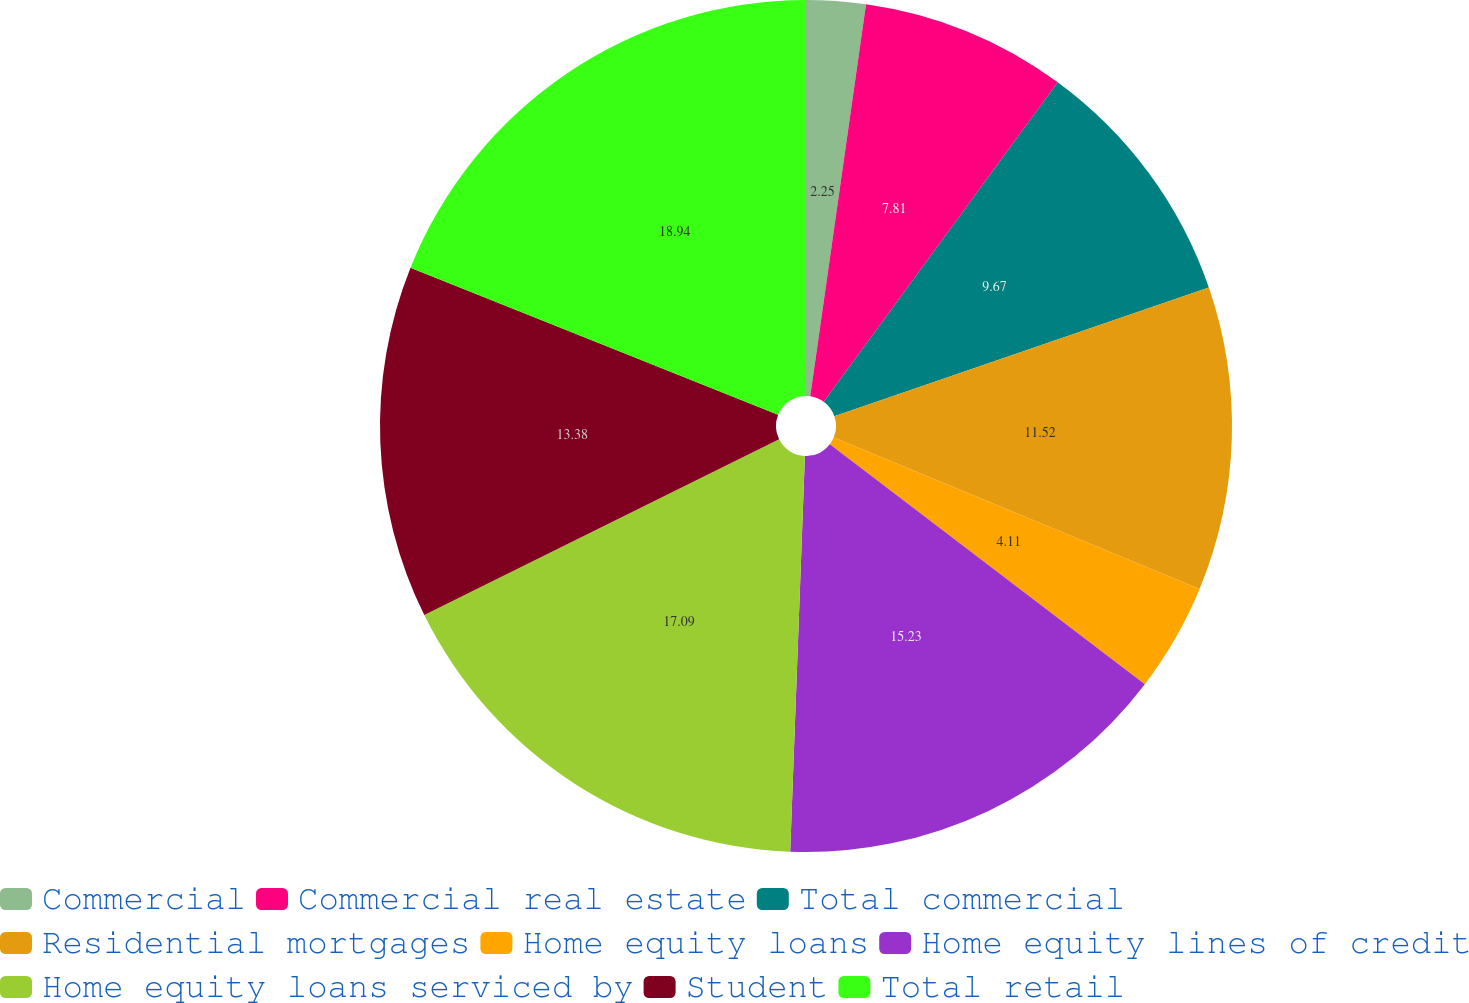Convert chart to OTSL. <chart><loc_0><loc_0><loc_500><loc_500><pie_chart><fcel>Commercial<fcel>Commercial real estate<fcel>Total commercial<fcel>Residential mortgages<fcel>Home equity loans<fcel>Home equity lines of credit<fcel>Home equity loans serviced by<fcel>Student<fcel>Total retail<nl><fcel>2.25%<fcel>7.81%<fcel>9.67%<fcel>11.52%<fcel>4.11%<fcel>15.23%<fcel>17.09%<fcel>13.38%<fcel>18.94%<nl></chart> 